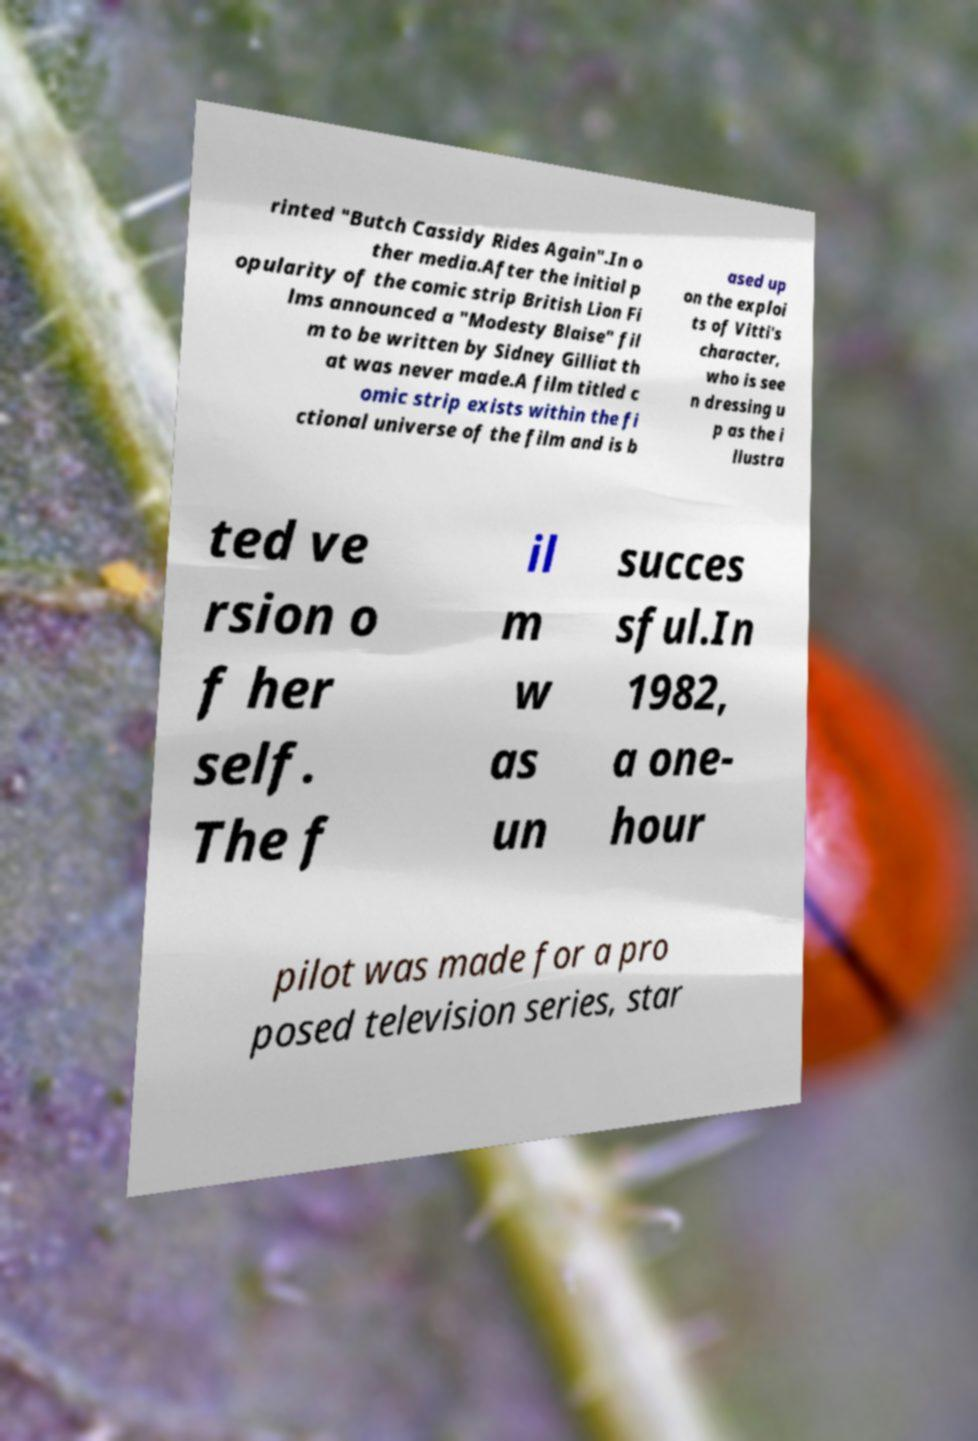What messages or text are displayed in this image? I need them in a readable, typed format. rinted "Butch Cassidy Rides Again".In o ther media.After the initial p opularity of the comic strip British Lion Fi lms announced a "Modesty Blaise" fil m to be written by Sidney Gilliat th at was never made.A film titled c omic strip exists within the fi ctional universe of the film and is b ased up on the exploi ts of Vitti's character, who is see n dressing u p as the i llustra ted ve rsion o f her self. The f il m w as un succes sful.In 1982, a one- hour pilot was made for a pro posed television series, star 